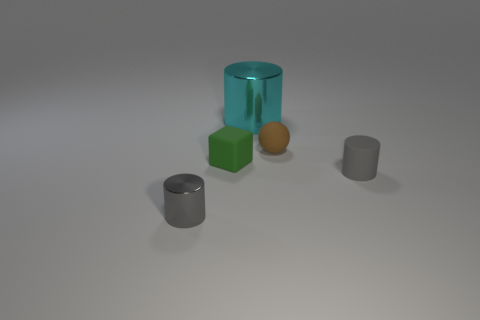Subtract all gray cylinders. How many cylinders are left? 1 Add 3 red metallic cylinders. How many objects exist? 8 Subtract all yellow spheres. How many gray cylinders are left? 2 Subtract all gray cylinders. How many cylinders are left? 1 Subtract all blocks. How many objects are left? 4 Subtract 2 cylinders. How many cylinders are left? 1 Subtract all large cyan objects. Subtract all brown things. How many objects are left? 3 Add 2 cyan things. How many cyan things are left? 3 Add 1 large metallic cylinders. How many large metallic cylinders exist? 2 Subtract 0 yellow balls. How many objects are left? 5 